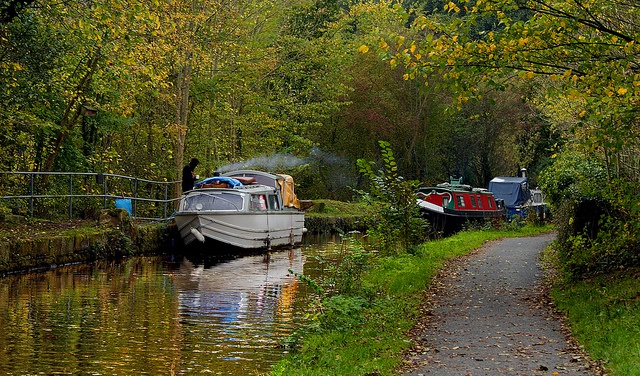Describe the objects in this image and their specific colors. I can see boat in black, darkgray, and gray tones, boat in black, maroon, and gray tones, and people in black, maroon, brown, and darkgreen tones in this image. 